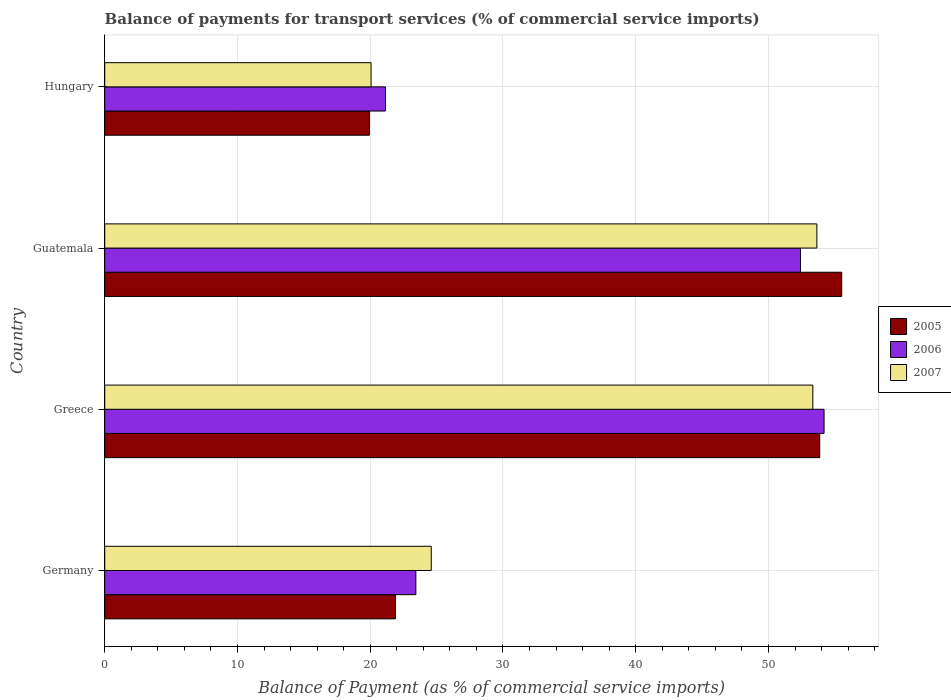How many different coloured bars are there?
Your answer should be compact. 3. How many groups of bars are there?
Your answer should be compact. 4. How many bars are there on the 2nd tick from the top?
Provide a short and direct response. 3. What is the label of the 2nd group of bars from the top?
Your response must be concise. Guatemala. In how many cases, is the number of bars for a given country not equal to the number of legend labels?
Ensure brevity in your answer.  0. What is the balance of payments for transport services in 2005 in Hungary?
Provide a short and direct response. 19.94. Across all countries, what is the maximum balance of payments for transport services in 2007?
Keep it short and to the point. 53.64. Across all countries, what is the minimum balance of payments for transport services in 2005?
Your answer should be very brief. 19.94. In which country was the balance of payments for transport services in 2005 maximum?
Your answer should be compact. Guatemala. In which country was the balance of payments for transport services in 2006 minimum?
Give a very brief answer. Hungary. What is the total balance of payments for transport services in 2007 in the graph?
Make the answer very short. 151.64. What is the difference between the balance of payments for transport services in 2007 in Guatemala and that in Hungary?
Ensure brevity in your answer.  33.58. What is the difference between the balance of payments for transport services in 2007 in Greece and the balance of payments for transport services in 2006 in Germany?
Provide a short and direct response. 29.9. What is the average balance of payments for transport services in 2006 per country?
Make the answer very short. 37.79. What is the difference between the balance of payments for transport services in 2006 and balance of payments for transport services in 2005 in Hungary?
Provide a succinct answer. 1.21. What is the ratio of the balance of payments for transport services in 2007 in Germany to that in Hungary?
Your answer should be very brief. 1.23. What is the difference between the highest and the second highest balance of payments for transport services in 2005?
Give a very brief answer. 1.66. What is the difference between the highest and the lowest balance of payments for transport services in 2007?
Offer a very short reply. 33.58. Is the sum of the balance of payments for transport services in 2005 in Germany and Greece greater than the maximum balance of payments for transport services in 2006 across all countries?
Provide a short and direct response. Yes. What does the 3rd bar from the top in Hungary represents?
Your answer should be compact. 2005. Is it the case that in every country, the sum of the balance of payments for transport services in 2005 and balance of payments for transport services in 2007 is greater than the balance of payments for transport services in 2006?
Ensure brevity in your answer.  Yes. How many countries are there in the graph?
Make the answer very short. 4. Are the values on the major ticks of X-axis written in scientific E-notation?
Provide a short and direct response. No. Does the graph contain grids?
Your answer should be compact. Yes. Where does the legend appear in the graph?
Give a very brief answer. Center right. How many legend labels are there?
Keep it short and to the point. 3. How are the legend labels stacked?
Offer a very short reply. Vertical. What is the title of the graph?
Provide a succinct answer. Balance of payments for transport services (% of commercial service imports). Does "1982" appear as one of the legend labels in the graph?
Keep it short and to the point. No. What is the label or title of the X-axis?
Provide a short and direct response. Balance of Payment (as % of commercial service imports). What is the Balance of Payment (as % of commercial service imports) of 2005 in Germany?
Ensure brevity in your answer.  21.91. What is the Balance of Payment (as % of commercial service imports) of 2006 in Germany?
Your answer should be very brief. 23.44. What is the Balance of Payment (as % of commercial service imports) of 2007 in Germany?
Offer a very short reply. 24.6. What is the Balance of Payment (as % of commercial service imports) in 2005 in Greece?
Offer a very short reply. 53.86. What is the Balance of Payment (as % of commercial service imports) of 2006 in Greece?
Your answer should be compact. 54.19. What is the Balance of Payment (as % of commercial service imports) of 2007 in Greece?
Keep it short and to the point. 53.34. What is the Balance of Payment (as % of commercial service imports) of 2005 in Guatemala?
Your answer should be very brief. 55.52. What is the Balance of Payment (as % of commercial service imports) in 2006 in Guatemala?
Ensure brevity in your answer.  52.41. What is the Balance of Payment (as % of commercial service imports) in 2007 in Guatemala?
Provide a succinct answer. 53.64. What is the Balance of Payment (as % of commercial service imports) of 2005 in Hungary?
Your answer should be compact. 19.94. What is the Balance of Payment (as % of commercial service imports) of 2006 in Hungary?
Make the answer very short. 21.15. What is the Balance of Payment (as % of commercial service imports) in 2007 in Hungary?
Your answer should be very brief. 20.06. Across all countries, what is the maximum Balance of Payment (as % of commercial service imports) of 2005?
Provide a short and direct response. 55.52. Across all countries, what is the maximum Balance of Payment (as % of commercial service imports) in 2006?
Your response must be concise. 54.19. Across all countries, what is the maximum Balance of Payment (as % of commercial service imports) of 2007?
Your response must be concise. 53.64. Across all countries, what is the minimum Balance of Payment (as % of commercial service imports) in 2005?
Your answer should be compact. 19.94. Across all countries, what is the minimum Balance of Payment (as % of commercial service imports) of 2006?
Make the answer very short. 21.15. Across all countries, what is the minimum Balance of Payment (as % of commercial service imports) of 2007?
Ensure brevity in your answer.  20.06. What is the total Balance of Payment (as % of commercial service imports) of 2005 in the graph?
Provide a succinct answer. 151.22. What is the total Balance of Payment (as % of commercial service imports) of 2006 in the graph?
Ensure brevity in your answer.  151.18. What is the total Balance of Payment (as % of commercial service imports) of 2007 in the graph?
Give a very brief answer. 151.64. What is the difference between the Balance of Payment (as % of commercial service imports) in 2005 in Germany and that in Greece?
Offer a very short reply. -31.95. What is the difference between the Balance of Payment (as % of commercial service imports) of 2006 in Germany and that in Greece?
Provide a succinct answer. -30.75. What is the difference between the Balance of Payment (as % of commercial service imports) of 2007 in Germany and that in Greece?
Make the answer very short. -28.74. What is the difference between the Balance of Payment (as % of commercial service imports) of 2005 in Germany and that in Guatemala?
Provide a succinct answer. -33.61. What is the difference between the Balance of Payment (as % of commercial service imports) in 2006 in Germany and that in Guatemala?
Make the answer very short. -28.97. What is the difference between the Balance of Payment (as % of commercial service imports) in 2007 in Germany and that in Guatemala?
Offer a very short reply. -29.05. What is the difference between the Balance of Payment (as % of commercial service imports) of 2005 in Germany and that in Hungary?
Provide a succinct answer. 1.97. What is the difference between the Balance of Payment (as % of commercial service imports) in 2006 in Germany and that in Hungary?
Your answer should be very brief. 2.29. What is the difference between the Balance of Payment (as % of commercial service imports) in 2007 in Germany and that in Hungary?
Offer a very short reply. 4.53. What is the difference between the Balance of Payment (as % of commercial service imports) of 2005 in Greece and that in Guatemala?
Make the answer very short. -1.66. What is the difference between the Balance of Payment (as % of commercial service imports) of 2006 in Greece and that in Guatemala?
Your response must be concise. 1.78. What is the difference between the Balance of Payment (as % of commercial service imports) in 2007 in Greece and that in Guatemala?
Offer a terse response. -0.3. What is the difference between the Balance of Payment (as % of commercial service imports) of 2005 in Greece and that in Hungary?
Keep it short and to the point. 33.92. What is the difference between the Balance of Payment (as % of commercial service imports) in 2006 in Greece and that in Hungary?
Keep it short and to the point. 33.04. What is the difference between the Balance of Payment (as % of commercial service imports) in 2007 in Greece and that in Hungary?
Provide a succinct answer. 33.28. What is the difference between the Balance of Payment (as % of commercial service imports) of 2005 in Guatemala and that in Hungary?
Keep it short and to the point. 35.58. What is the difference between the Balance of Payment (as % of commercial service imports) of 2006 in Guatemala and that in Hungary?
Offer a terse response. 31.26. What is the difference between the Balance of Payment (as % of commercial service imports) in 2007 in Guatemala and that in Hungary?
Offer a very short reply. 33.58. What is the difference between the Balance of Payment (as % of commercial service imports) in 2005 in Germany and the Balance of Payment (as % of commercial service imports) in 2006 in Greece?
Your answer should be very brief. -32.28. What is the difference between the Balance of Payment (as % of commercial service imports) in 2005 in Germany and the Balance of Payment (as % of commercial service imports) in 2007 in Greece?
Offer a terse response. -31.43. What is the difference between the Balance of Payment (as % of commercial service imports) in 2006 in Germany and the Balance of Payment (as % of commercial service imports) in 2007 in Greece?
Make the answer very short. -29.9. What is the difference between the Balance of Payment (as % of commercial service imports) in 2005 in Germany and the Balance of Payment (as % of commercial service imports) in 2006 in Guatemala?
Make the answer very short. -30.5. What is the difference between the Balance of Payment (as % of commercial service imports) of 2005 in Germany and the Balance of Payment (as % of commercial service imports) of 2007 in Guatemala?
Your response must be concise. -31.74. What is the difference between the Balance of Payment (as % of commercial service imports) in 2006 in Germany and the Balance of Payment (as % of commercial service imports) in 2007 in Guatemala?
Provide a succinct answer. -30.21. What is the difference between the Balance of Payment (as % of commercial service imports) of 2005 in Germany and the Balance of Payment (as % of commercial service imports) of 2006 in Hungary?
Your response must be concise. 0.76. What is the difference between the Balance of Payment (as % of commercial service imports) of 2005 in Germany and the Balance of Payment (as % of commercial service imports) of 2007 in Hungary?
Keep it short and to the point. 1.84. What is the difference between the Balance of Payment (as % of commercial service imports) in 2006 in Germany and the Balance of Payment (as % of commercial service imports) in 2007 in Hungary?
Keep it short and to the point. 3.37. What is the difference between the Balance of Payment (as % of commercial service imports) in 2005 in Greece and the Balance of Payment (as % of commercial service imports) in 2006 in Guatemala?
Give a very brief answer. 1.45. What is the difference between the Balance of Payment (as % of commercial service imports) in 2005 in Greece and the Balance of Payment (as % of commercial service imports) in 2007 in Guatemala?
Your answer should be very brief. 0.22. What is the difference between the Balance of Payment (as % of commercial service imports) of 2006 in Greece and the Balance of Payment (as % of commercial service imports) of 2007 in Guatemala?
Offer a very short reply. 0.54. What is the difference between the Balance of Payment (as % of commercial service imports) in 2005 in Greece and the Balance of Payment (as % of commercial service imports) in 2006 in Hungary?
Make the answer very short. 32.71. What is the difference between the Balance of Payment (as % of commercial service imports) in 2005 in Greece and the Balance of Payment (as % of commercial service imports) in 2007 in Hungary?
Ensure brevity in your answer.  33.8. What is the difference between the Balance of Payment (as % of commercial service imports) of 2006 in Greece and the Balance of Payment (as % of commercial service imports) of 2007 in Hungary?
Your response must be concise. 34.12. What is the difference between the Balance of Payment (as % of commercial service imports) in 2005 in Guatemala and the Balance of Payment (as % of commercial service imports) in 2006 in Hungary?
Provide a succinct answer. 34.37. What is the difference between the Balance of Payment (as % of commercial service imports) in 2005 in Guatemala and the Balance of Payment (as % of commercial service imports) in 2007 in Hungary?
Your response must be concise. 35.45. What is the difference between the Balance of Payment (as % of commercial service imports) in 2006 in Guatemala and the Balance of Payment (as % of commercial service imports) in 2007 in Hungary?
Make the answer very short. 32.35. What is the average Balance of Payment (as % of commercial service imports) of 2005 per country?
Provide a short and direct response. 37.8. What is the average Balance of Payment (as % of commercial service imports) in 2006 per country?
Ensure brevity in your answer.  37.79. What is the average Balance of Payment (as % of commercial service imports) in 2007 per country?
Ensure brevity in your answer.  37.91. What is the difference between the Balance of Payment (as % of commercial service imports) in 2005 and Balance of Payment (as % of commercial service imports) in 2006 in Germany?
Provide a short and direct response. -1.53. What is the difference between the Balance of Payment (as % of commercial service imports) of 2005 and Balance of Payment (as % of commercial service imports) of 2007 in Germany?
Keep it short and to the point. -2.69. What is the difference between the Balance of Payment (as % of commercial service imports) of 2006 and Balance of Payment (as % of commercial service imports) of 2007 in Germany?
Offer a terse response. -1.16. What is the difference between the Balance of Payment (as % of commercial service imports) of 2005 and Balance of Payment (as % of commercial service imports) of 2006 in Greece?
Give a very brief answer. -0.33. What is the difference between the Balance of Payment (as % of commercial service imports) of 2005 and Balance of Payment (as % of commercial service imports) of 2007 in Greece?
Your response must be concise. 0.52. What is the difference between the Balance of Payment (as % of commercial service imports) of 2006 and Balance of Payment (as % of commercial service imports) of 2007 in Greece?
Offer a very short reply. 0.85. What is the difference between the Balance of Payment (as % of commercial service imports) of 2005 and Balance of Payment (as % of commercial service imports) of 2006 in Guatemala?
Your response must be concise. 3.11. What is the difference between the Balance of Payment (as % of commercial service imports) of 2005 and Balance of Payment (as % of commercial service imports) of 2007 in Guatemala?
Your answer should be compact. 1.87. What is the difference between the Balance of Payment (as % of commercial service imports) of 2006 and Balance of Payment (as % of commercial service imports) of 2007 in Guatemala?
Provide a short and direct response. -1.24. What is the difference between the Balance of Payment (as % of commercial service imports) of 2005 and Balance of Payment (as % of commercial service imports) of 2006 in Hungary?
Make the answer very short. -1.21. What is the difference between the Balance of Payment (as % of commercial service imports) of 2005 and Balance of Payment (as % of commercial service imports) of 2007 in Hungary?
Your response must be concise. -0.12. What is the difference between the Balance of Payment (as % of commercial service imports) of 2006 and Balance of Payment (as % of commercial service imports) of 2007 in Hungary?
Give a very brief answer. 1.08. What is the ratio of the Balance of Payment (as % of commercial service imports) in 2005 in Germany to that in Greece?
Make the answer very short. 0.41. What is the ratio of the Balance of Payment (as % of commercial service imports) in 2006 in Germany to that in Greece?
Give a very brief answer. 0.43. What is the ratio of the Balance of Payment (as % of commercial service imports) in 2007 in Germany to that in Greece?
Provide a short and direct response. 0.46. What is the ratio of the Balance of Payment (as % of commercial service imports) of 2005 in Germany to that in Guatemala?
Your response must be concise. 0.39. What is the ratio of the Balance of Payment (as % of commercial service imports) of 2006 in Germany to that in Guatemala?
Provide a short and direct response. 0.45. What is the ratio of the Balance of Payment (as % of commercial service imports) of 2007 in Germany to that in Guatemala?
Your answer should be very brief. 0.46. What is the ratio of the Balance of Payment (as % of commercial service imports) of 2005 in Germany to that in Hungary?
Offer a terse response. 1.1. What is the ratio of the Balance of Payment (as % of commercial service imports) in 2006 in Germany to that in Hungary?
Your answer should be very brief. 1.11. What is the ratio of the Balance of Payment (as % of commercial service imports) in 2007 in Germany to that in Hungary?
Offer a terse response. 1.23. What is the ratio of the Balance of Payment (as % of commercial service imports) in 2005 in Greece to that in Guatemala?
Give a very brief answer. 0.97. What is the ratio of the Balance of Payment (as % of commercial service imports) in 2006 in Greece to that in Guatemala?
Offer a very short reply. 1.03. What is the ratio of the Balance of Payment (as % of commercial service imports) of 2005 in Greece to that in Hungary?
Ensure brevity in your answer.  2.7. What is the ratio of the Balance of Payment (as % of commercial service imports) in 2006 in Greece to that in Hungary?
Provide a short and direct response. 2.56. What is the ratio of the Balance of Payment (as % of commercial service imports) in 2007 in Greece to that in Hungary?
Offer a terse response. 2.66. What is the ratio of the Balance of Payment (as % of commercial service imports) in 2005 in Guatemala to that in Hungary?
Keep it short and to the point. 2.78. What is the ratio of the Balance of Payment (as % of commercial service imports) in 2006 in Guatemala to that in Hungary?
Your answer should be very brief. 2.48. What is the ratio of the Balance of Payment (as % of commercial service imports) of 2007 in Guatemala to that in Hungary?
Provide a short and direct response. 2.67. What is the difference between the highest and the second highest Balance of Payment (as % of commercial service imports) in 2005?
Keep it short and to the point. 1.66. What is the difference between the highest and the second highest Balance of Payment (as % of commercial service imports) of 2006?
Your answer should be very brief. 1.78. What is the difference between the highest and the second highest Balance of Payment (as % of commercial service imports) in 2007?
Ensure brevity in your answer.  0.3. What is the difference between the highest and the lowest Balance of Payment (as % of commercial service imports) of 2005?
Your answer should be very brief. 35.58. What is the difference between the highest and the lowest Balance of Payment (as % of commercial service imports) in 2006?
Give a very brief answer. 33.04. What is the difference between the highest and the lowest Balance of Payment (as % of commercial service imports) of 2007?
Offer a very short reply. 33.58. 